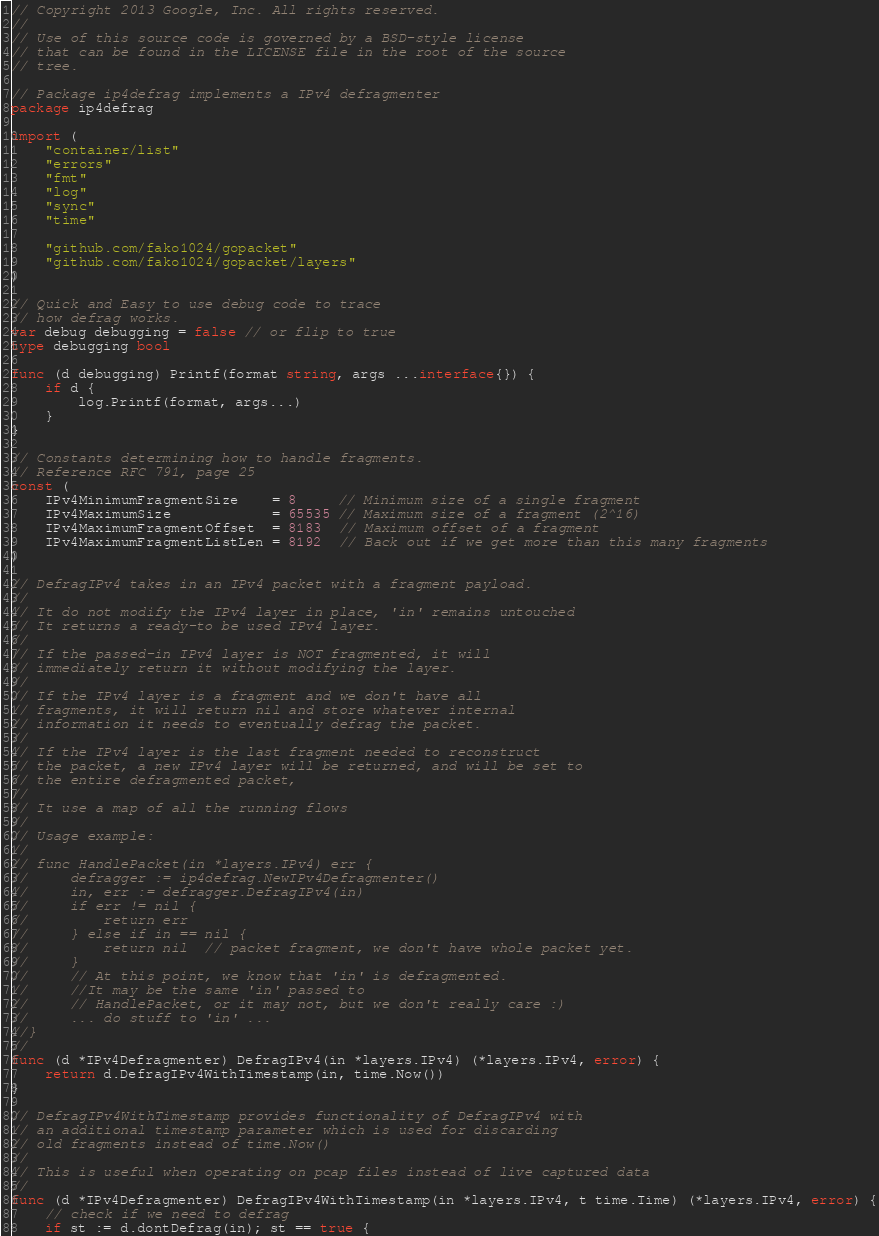<code> <loc_0><loc_0><loc_500><loc_500><_Go_>// Copyright 2013 Google, Inc. All rights reserved.
//
// Use of this source code is governed by a BSD-style license
// that can be found in the LICENSE file in the root of the source
// tree.

// Package ip4defrag implements a IPv4 defragmenter
package ip4defrag

import (
	"container/list"
	"errors"
	"fmt"
	"log"
	"sync"
	"time"

	"github.com/fako1024/gopacket"
	"github.com/fako1024/gopacket/layers"
)

// Quick and Easy to use debug code to trace
// how defrag works.
var debug debugging = false // or flip to true
type debugging bool

func (d debugging) Printf(format string, args ...interface{}) {
	if d {
		log.Printf(format, args...)
	}
}

// Constants determining how to handle fragments.
// Reference RFC 791, page 25
const (
	IPv4MinimumFragmentSize    = 8     // Minimum size of a single fragment
	IPv4MaximumSize            = 65535 // Maximum size of a fragment (2^16)
	IPv4MaximumFragmentOffset  = 8183  // Maximum offset of a fragment
	IPv4MaximumFragmentListLen = 8192  // Back out if we get more than this many fragments
)

// DefragIPv4 takes in an IPv4 packet with a fragment payload.
//
// It do not modify the IPv4 layer in place, 'in' remains untouched
// It returns a ready-to be used IPv4 layer.
//
// If the passed-in IPv4 layer is NOT fragmented, it will
// immediately return it without modifying the layer.
//
// If the IPv4 layer is a fragment and we don't have all
// fragments, it will return nil and store whatever internal
// information it needs to eventually defrag the packet.
//
// If the IPv4 layer is the last fragment needed to reconstruct
// the packet, a new IPv4 layer will be returned, and will be set to
// the entire defragmented packet,
//
// It use a map of all the running flows
//
// Usage example:
//
// func HandlePacket(in *layers.IPv4) err {
//     defragger := ip4defrag.NewIPv4Defragmenter()
//     in, err := defragger.DefragIPv4(in)
//     if err != nil {
//         return err
//     } else if in == nil {
//         return nil  // packet fragment, we don't have whole packet yet.
//     }
//     // At this point, we know that 'in' is defragmented.
//     //It may be the same 'in' passed to
//	   // HandlePacket, or it may not, but we don't really care :)
//	   ... do stuff to 'in' ...
//}
//
func (d *IPv4Defragmenter) DefragIPv4(in *layers.IPv4) (*layers.IPv4, error) {
	return d.DefragIPv4WithTimestamp(in, time.Now())
}

// DefragIPv4WithTimestamp provides functionality of DefragIPv4 with
// an additional timestamp parameter which is used for discarding
// old fragments instead of time.Now()
//
// This is useful when operating on pcap files instead of live captured data
//
func (d *IPv4Defragmenter) DefragIPv4WithTimestamp(in *layers.IPv4, t time.Time) (*layers.IPv4, error) {
	// check if we need to defrag
	if st := d.dontDefrag(in); st == true {</code> 